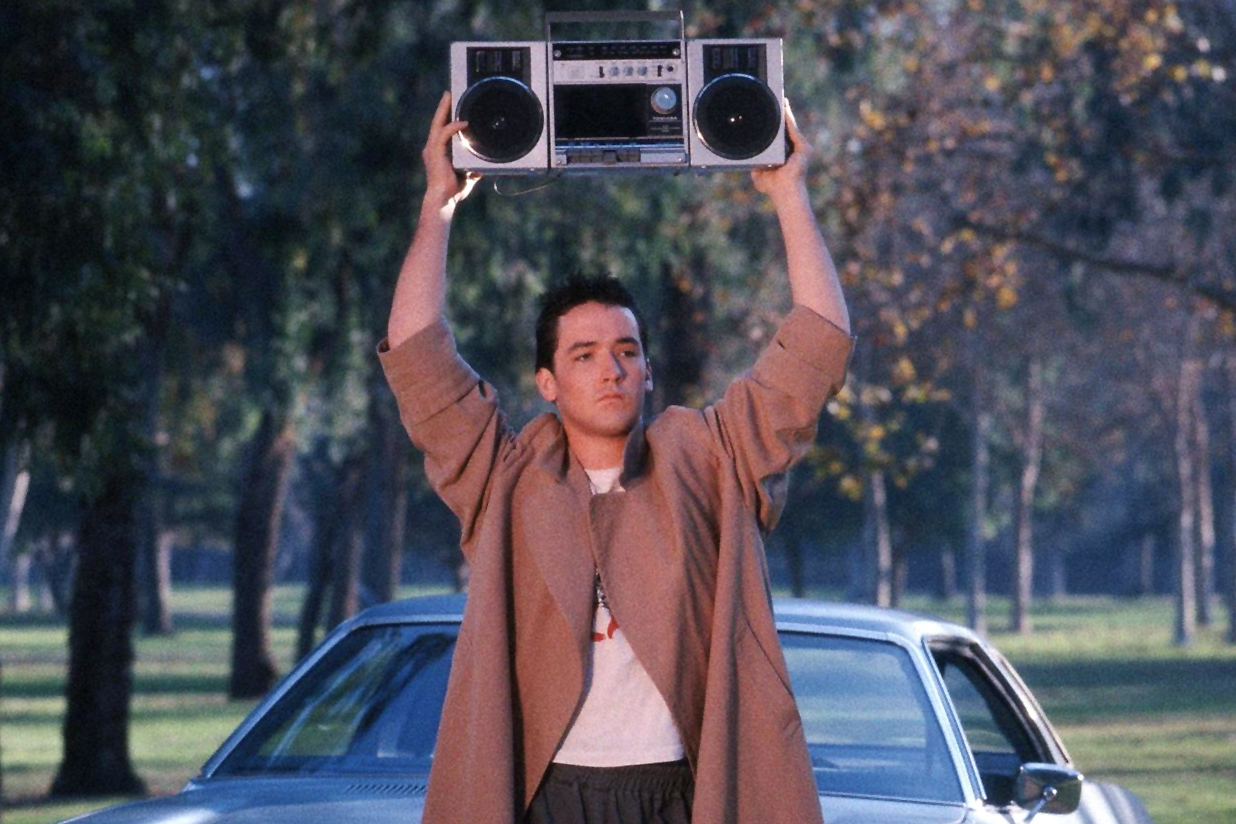Analyze the character of Lloyd Dobler based on what he's doing in this scene. Lloyd Dobler's character is richly illustrated through his actions in this scene. Holding a boombox aloft, he demonstrates bravery, vulnerability, and an all-consuming commitment to his feelings. His choice to publicly express his love through a dramatic and unconventional gesture indicates a fearless, perhaps slightly reckless, streak in his personality. It shows that he values authenticity and emotional honesty, prioritizing these over societal norms or personal pride. His determined posture and focused expression suggest a depth of feeling that goes beyond infatuation; this is an earnest bid to communicate a profound emotional truth. Lloyd's character is creative, resourceful, and wholeheartedly devoted, making him a compelling and relatable figure in the narrative. 